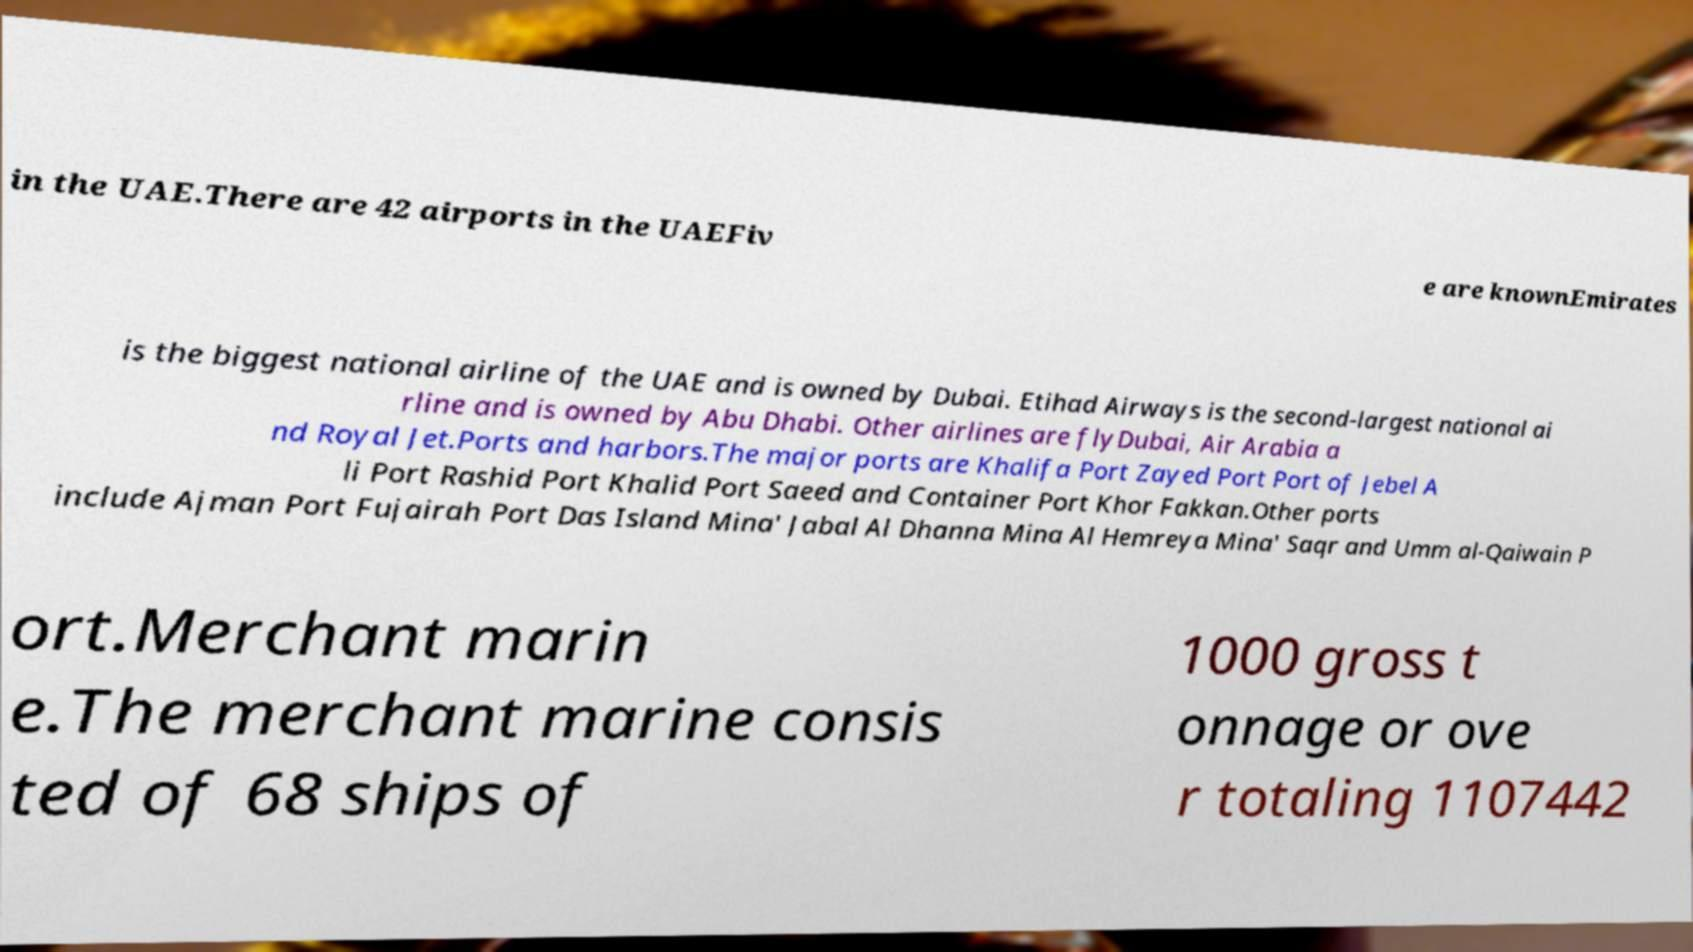Can you accurately transcribe the text from the provided image for me? in the UAE.There are 42 airports in the UAEFiv e are knownEmirates is the biggest national airline of the UAE and is owned by Dubai. Etihad Airways is the second-largest national ai rline and is owned by Abu Dhabi. Other airlines are flyDubai, Air Arabia a nd Royal Jet.Ports and harbors.The major ports are Khalifa Port Zayed Port Port of Jebel A li Port Rashid Port Khalid Port Saeed and Container Port Khor Fakkan.Other ports include Ajman Port Fujairah Port Das Island Mina' Jabal Al Dhanna Mina Al Hemreya Mina' Saqr and Umm al-Qaiwain P ort.Merchant marin e.The merchant marine consis ted of 68 ships of 1000 gross t onnage or ove r totaling 1107442 